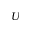<formula> <loc_0><loc_0><loc_500><loc_500>U</formula> 